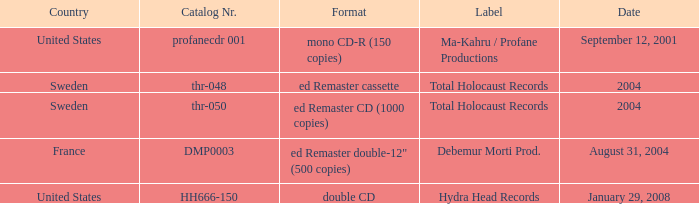Which date has Total Holocaust records in the ed Remaster cassette format? 2004.0. 